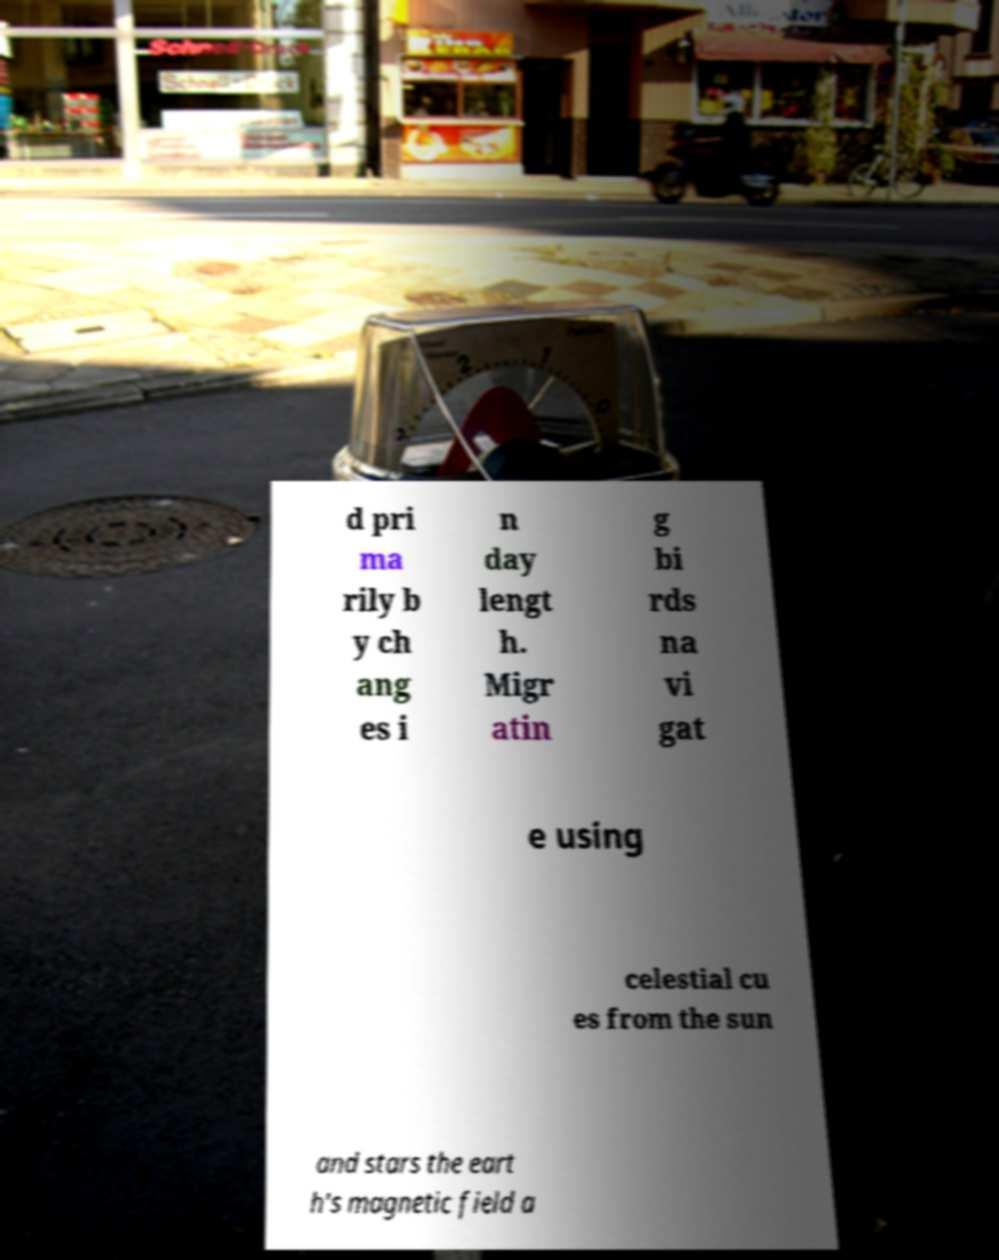Can you accurately transcribe the text from the provided image for me? d pri ma rily b y ch ang es i n day lengt h. Migr atin g bi rds na vi gat e using celestial cu es from the sun and stars the eart h's magnetic field a 